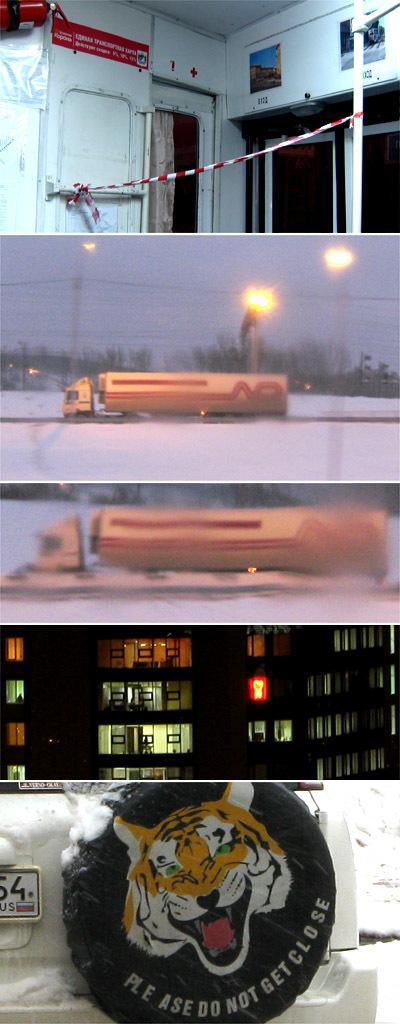In one or two sentences, can you explain what this image depicts? This is the college. In the first image we can see white color wall, door and pole. In the second image truck and poles are there. In the third image we can see a vehicle. In the forth image building is there. One tier is attached to the backside of the car and we can see number plate of car. 